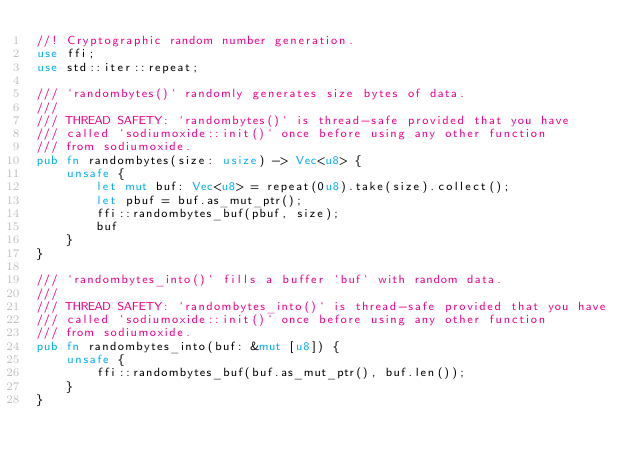<code> <loc_0><loc_0><loc_500><loc_500><_Rust_>//! Cryptographic random number generation.
use ffi;
use std::iter::repeat;

/// `randombytes()` randomly generates size bytes of data.
///
/// THREAD SAFETY: `randombytes()` is thread-safe provided that you have
/// called `sodiumoxide::init()` once before using any other function
/// from sodiumoxide.
pub fn randombytes(size: usize) -> Vec<u8> {
    unsafe {
        let mut buf: Vec<u8> = repeat(0u8).take(size).collect();
        let pbuf = buf.as_mut_ptr();
        ffi::randombytes_buf(pbuf, size);
        buf
    }
}

/// `randombytes_into()` fills a buffer `buf` with random data.
///
/// THREAD SAFETY: `randombytes_into()` is thread-safe provided that you have
/// called `sodiumoxide::init()` once before using any other function
/// from sodiumoxide.
pub fn randombytes_into(buf: &mut [u8]) {
    unsafe {
        ffi::randombytes_buf(buf.as_mut_ptr(), buf.len());
    }
}
</code> 